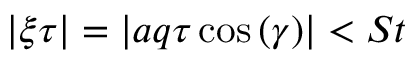Convert formula to latex. <formula><loc_0><loc_0><loc_500><loc_500>| \xi \tau | = | a q \tau \cos { ( \gamma ) } | < S t</formula> 